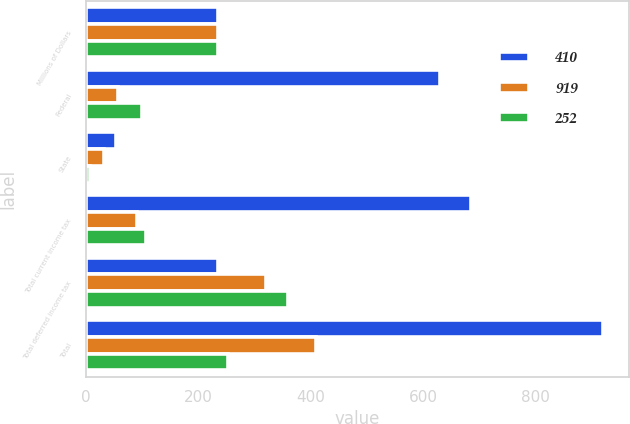<chart> <loc_0><loc_0><loc_500><loc_500><stacked_bar_chart><ecel><fcel>Millions of Dollars<fcel>Federal<fcel>State<fcel>Total current income tax<fcel>Total deferred income tax<fcel>Total<nl><fcel>410<fcel>235<fcel>630<fcel>54<fcel>684<fcel>235<fcel>919<nl><fcel>919<fcel>235<fcel>57<fcel>33<fcel>90<fcel>320<fcel>410<nl><fcel>252<fcel>235<fcel>99<fcel>8<fcel>107<fcel>359<fcel>252<nl></chart> 